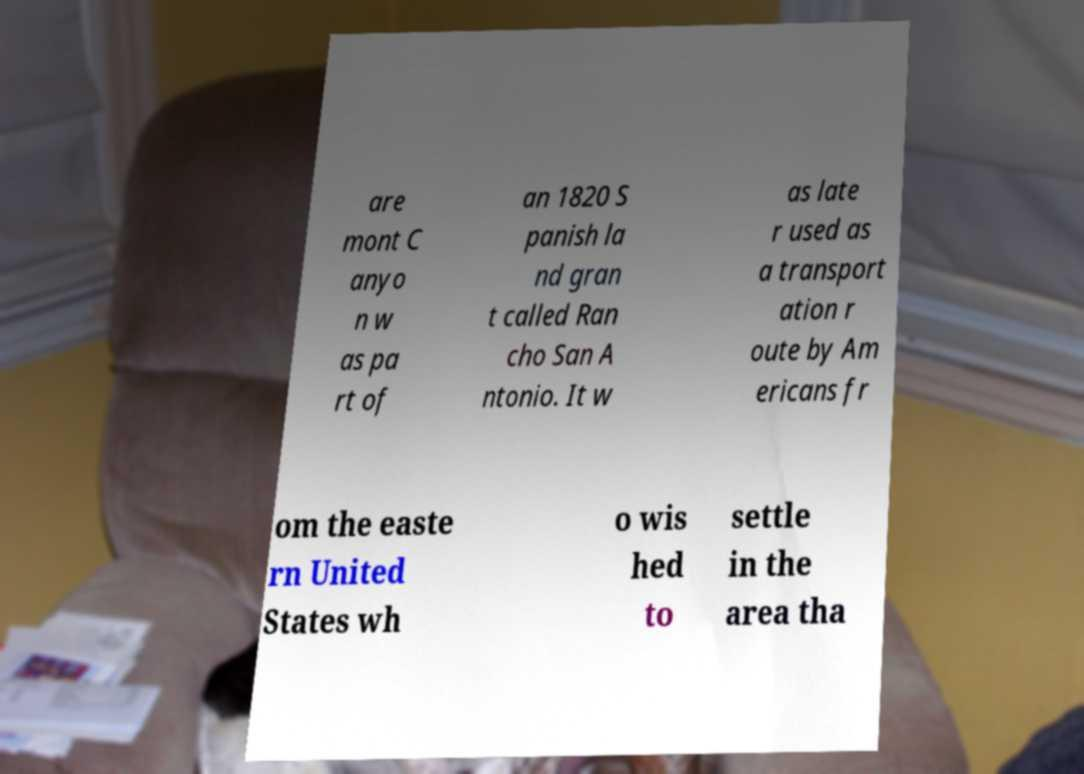I need the written content from this picture converted into text. Can you do that? are mont C anyo n w as pa rt of an 1820 S panish la nd gran t called Ran cho San A ntonio. It w as late r used as a transport ation r oute by Am ericans fr om the easte rn United States wh o wis hed to settle in the area tha 